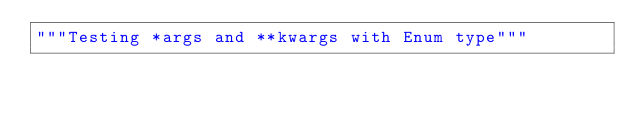Convert code to text. <code><loc_0><loc_0><loc_500><loc_500><_Python_>"""Testing *args and **kwargs with Enum type"""
</code> 